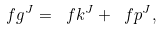Convert formula to latex. <formula><loc_0><loc_0><loc_500><loc_500>\ f g ^ { J } = \ f k ^ { J } + \ f p ^ { J } ,</formula> 